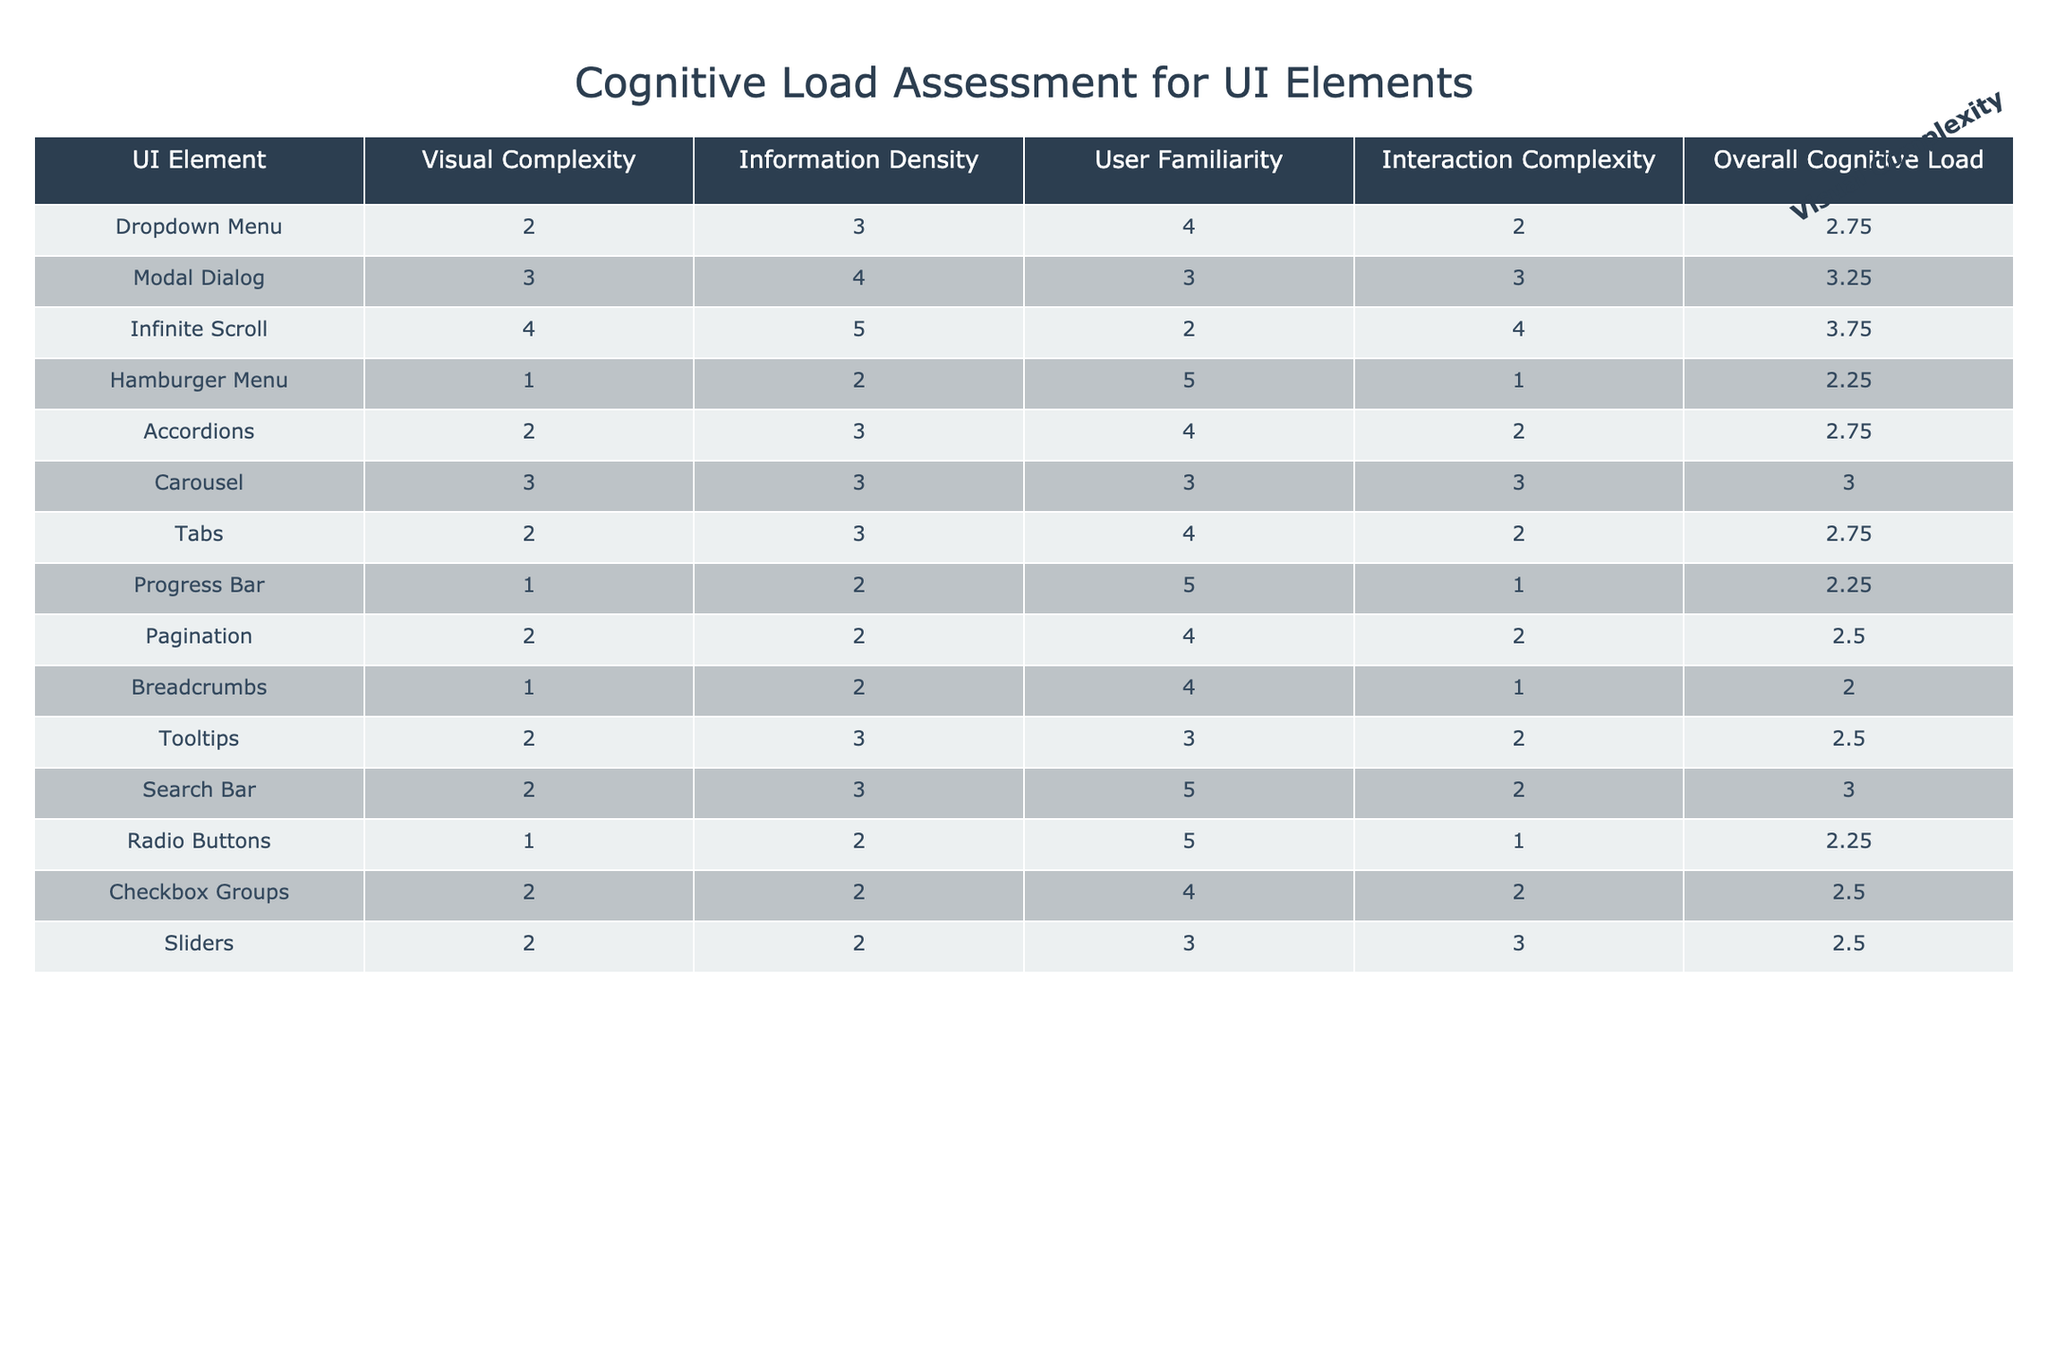What is the overall cognitive load of the Dropdown Menu? The overall cognitive load for the Dropdown Menu is listed in the table. It corresponds to the row for the Dropdown Menu, where the value under "Overall Cognitive Load" is 2.75.
Answer: 2.75 Which UI element has the highest information density? The highest value in the "Information Density" column indicates the UI element with the greatest information density. Upon reviewing the table, the Infinite Scroll has the highest value of 5.
Answer: Infinite Scroll Is the Modal Dialog more complex to interact with than the Accordion? To determine this, we compare the "Interaction Complexity" values for both the Modal Dialog (3) and the Accordion (2). Since 3 is greater than 2, it confirms that the Modal Dialog is indeed more complex to interact with.
Answer: Yes What is the average overall cognitive load of all UI elements? To find the average overall cognitive load, we sum all the values in the "Overall Cognitive Load" column, which adds up to 38.50, and divide by the number of UI elements (14). This results in an average of 2.75 (38.50/14 = 2.75).
Answer: 2.75 Do more familiar UI elements tend to have lower overall cognitive load? We compare the overall cognitive load of UI elements with high user familiarity versus those with low familiarity. By analyzing data, UI elements with the highest familiarity tend to have lower or similar cognitive load values. However, a detailed analysis reveals variability; thus, we cannot definitively conclude that higher familiarity always leads to lower cognitive load.
Answer: No Which UI element has the lowest visual complexity? To find this, we inspect the "Visual Complexity" column for the lowest number. The Hamburger Menu has the lowest value of 1.
Answer: Hamburger Menu How does the Information Density of Tabs compare with the Progress Bar? We compare the values in the "Information Density" column for Tabs (3) and Progress Bar (2). Since 3 is greater than 2, it indicates that Tabs have a higher information density than the Progress Bar.
Answer: Tabs have higher information density Identify the UI element with the second lowest overall cognitive load. We first list the overall cognitive loads in ascending order: Hamburger Menu (2.25), Progress Bar (2.25), Radio Buttons (2.25), Pagination (2.5), Checkbox Groups (2.5), Sliders (2.5), etc. The second lowest cognitive load belongs to Progress Bar, Radio Buttons, and Hamburger Menu, which share the same lowest value.
Answer: Progress Bar, Radio Buttons, and Hamburger Menu (tie) What is the total user familiarity value for all UI elements? By adding the "User Familiarity" values of all the UI elements listed in the table, the total is calculated as follows: 4 + 3 + 2 + 5 + 4 + 3 + 4 + 5 + 4 + 3 + 5 + 4 + 3 + 4 = 52.
Answer: 52 Are there any UI elements with the same overall cognitive load? We look for duplicate values in the "Overall Cognitive Load" column. The values of 2.25 (Hamburger Menu, Progress Bar, Radio Buttons) and 2.75 (Dropdown Menu, Accordions, Tabs) appear more than once, confirming that there are UI elements with the same overall cognitive load.
Answer: Yes 